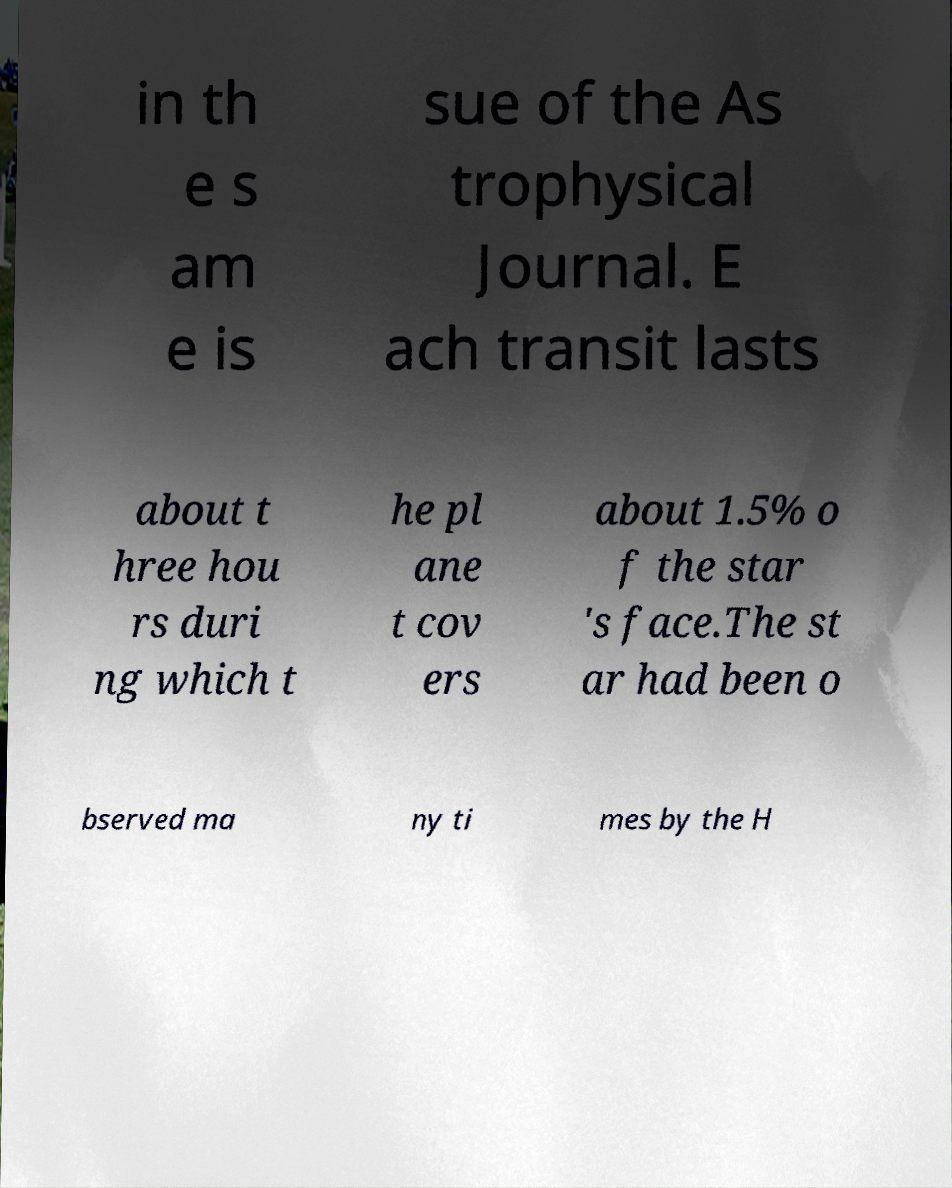There's text embedded in this image that I need extracted. Can you transcribe it verbatim? in th e s am e is sue of the As trophysical Journal. E ach transit lasts about t hree hou rs duri ng which t he pl ane t cov ers about 1.5% o f the star 's face.The st ar had been o bserved ma ny ti mes by the H 